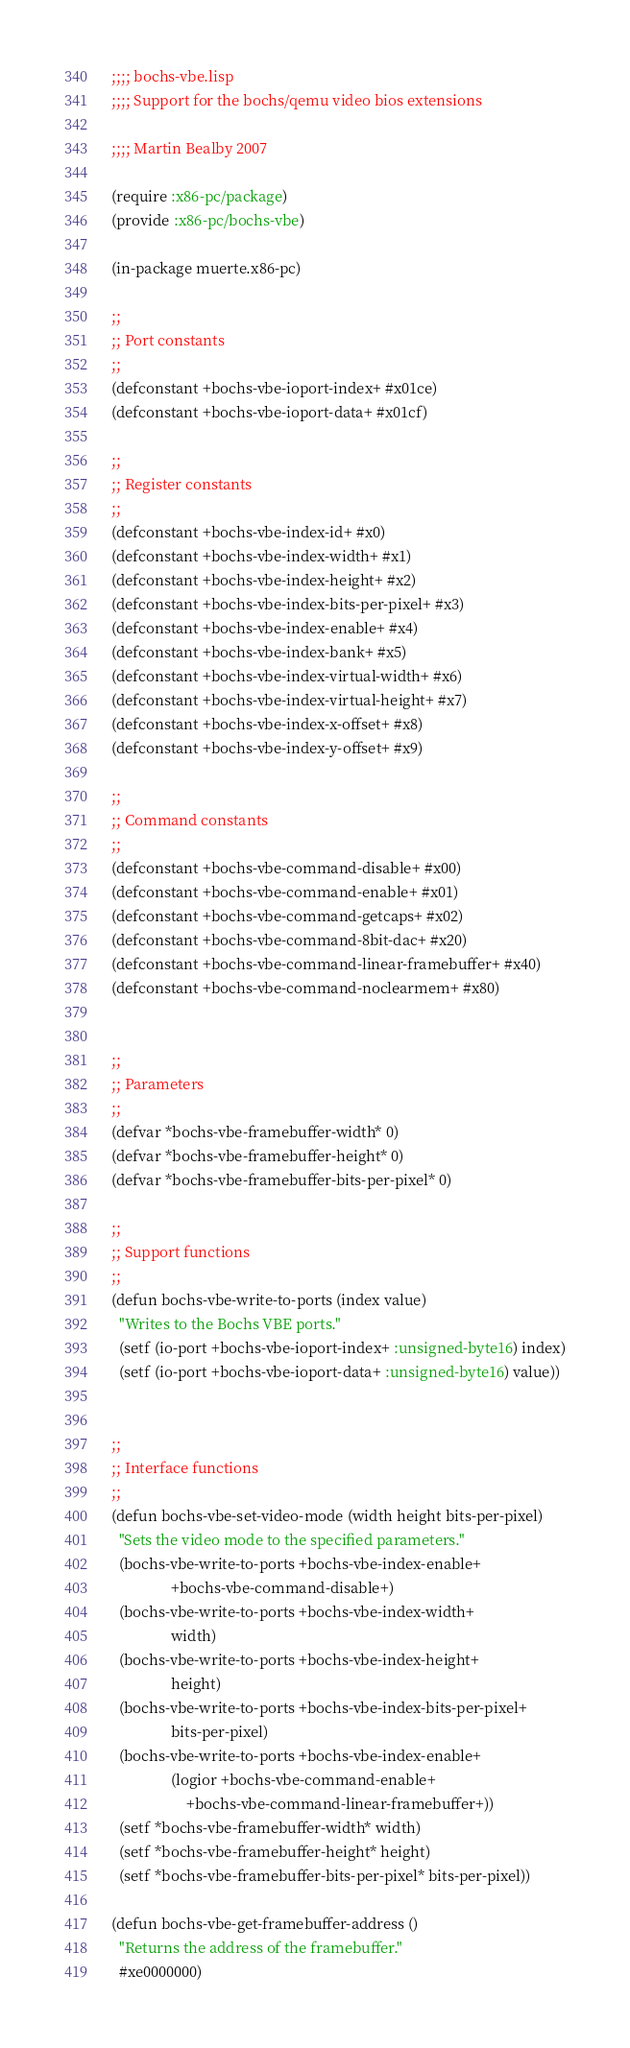Convert code to text. <code><loc_0><loc_0><loc_500><loc_500><_Lisp_>;;;; bochs-vbe.lisp
;;;; Support for the bochs/qemu video bios extensions

;;;; Martin Bealby 2007

(require :x86-pc/package)
(provide :x86-pc/bochs-vbe)

(in-package muerte.x86-pc)

;;
;; Port constants
;;
(defconstant +bochs-vbe-ioport-index+ #x01ce)
(defconstant +bochs-vbe-ioport-data+ #x01cf)

;;
;; Register constants
;;
(defconstant +bochs-vbe-index-id+ #x0)
(defconstant +bochs-vbe-index-width+ #x1)
(defconstant +bochs-vbe-index-height+ #x2)
(defconstant +bochs-vbe-index-bits-per-pixel+ #x3)
(defconstant +bochs-vbe-index-enable+ #x4)
(defconstant +bochs-vbe-index-bank+ #x5)
(defconstant +bochs-vbe-index-virtual-width+ #x6)
(defconstant +bochs-vbe-index-virtual-height+ #x7)
(defconstant +bochs-vbe-index-x-offset+ #x8)
(defconstant +bochs-vbe-index-y-offset+ #x9)

;;
;; Command constants
;;
(defconstant +bochs-vbe-command-disable+ #x00)
(defconstant +bochs-vbe-command-enable+ #x01)
(defconstant +bochs-vbe-command-getcaps+ #x02)
(defconstant +bochs-vbe-command-8bit-dac+ #x20)
(defconstant +bochs-vbe-command-linear-framebuffer+ #x40)
(defconstant +bochs-vbe-command-noclearmem+ #x80)


;;
;; Parameters
;;
(defvar *bochs-vbe-framebuffer-width* 0)
(defvar *bochs-vbe-framebuffer-height* 0)
(defvar *bochs-vbe-framebuffer-bits-per-pixel* 0)

;;
;; Support functions
;;
(defun bochs-vbe-write-to-ports (index value)
  "Writes to the Bochs VBE ports."
  (setf (io-port +bochs-vbe-ioport-index+ :unsigned-byte16) index)
  (setf (io-port +bochs-vbe-ioport-data+ :unsigned-byte16) value))


;;
;; Interface functions
;;
(defun bochs-vbe-set-video-mode (width height bits-per-pixel)
  "Sets the video mode to the specified parameters."
  (bochs-vbe-write-to-ports +bochs-vbe-index-enable+
			    +bochs-vbe-command-disable+)
  (bochs-vbe-write-to-ports +bochs-vbe-index-width+
			    width)
  (bochs-vbe-write-to-ports +bochs-vbe-index-height+
			    height)
  (bochs-vbe-write-to-ports +bochs-vbe-index-bits-per-pixel+
			    bits-per-pixel)
  (bochs-vbe-write-to-ports +bochs-vbe-index-enable+
			    (logior +bochs-vbe-command-enable+
				    +bochs-vbe-command-linear-framebuffer+))
  (setf *bochs-vbe-framebuffer-width* width)
  (setf *bochs-vbe-framebuffer-height* height)
  (setf *bochs-vbe-framebuffer-bits-per-pixel* bits-per-pixel))

(defun bochs-vbe-get-framebuffer-address ()
  "Returns the address of the framebuffer."
  #xe0000000)
</code> 